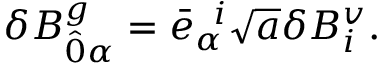Convert formula to latex. <formula><loc_0><loc_0><loc_500><loc_500>\delta B _ { \hat { 0 } \alpha } ^ { g } = { \bar { e } } _ { \alpha } ^ { \, i } \sqrt { a } \delta B _ { i } ^ { v } .</formula> 